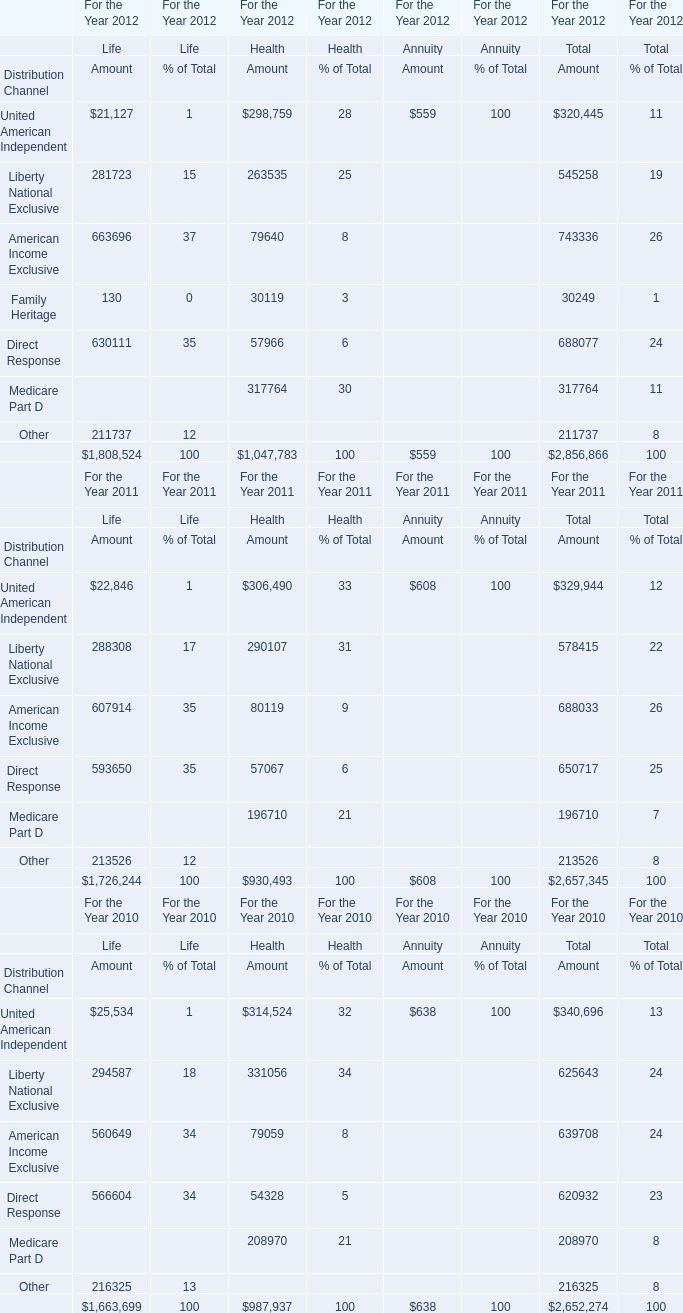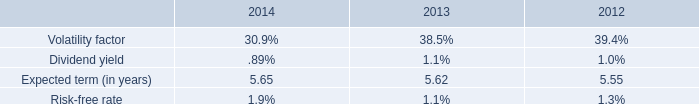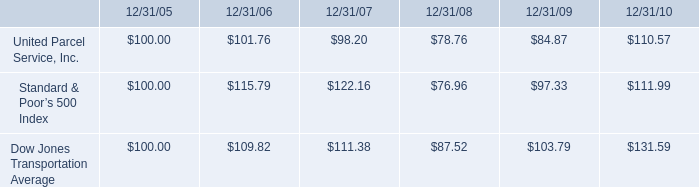what was the percentage cumulative total shareowners 2019 returns for united parcel service inc . for the five years ended 12/31/10? 
Computations: ((110.57 - 100) / 100)
Answer: 0.1057. 